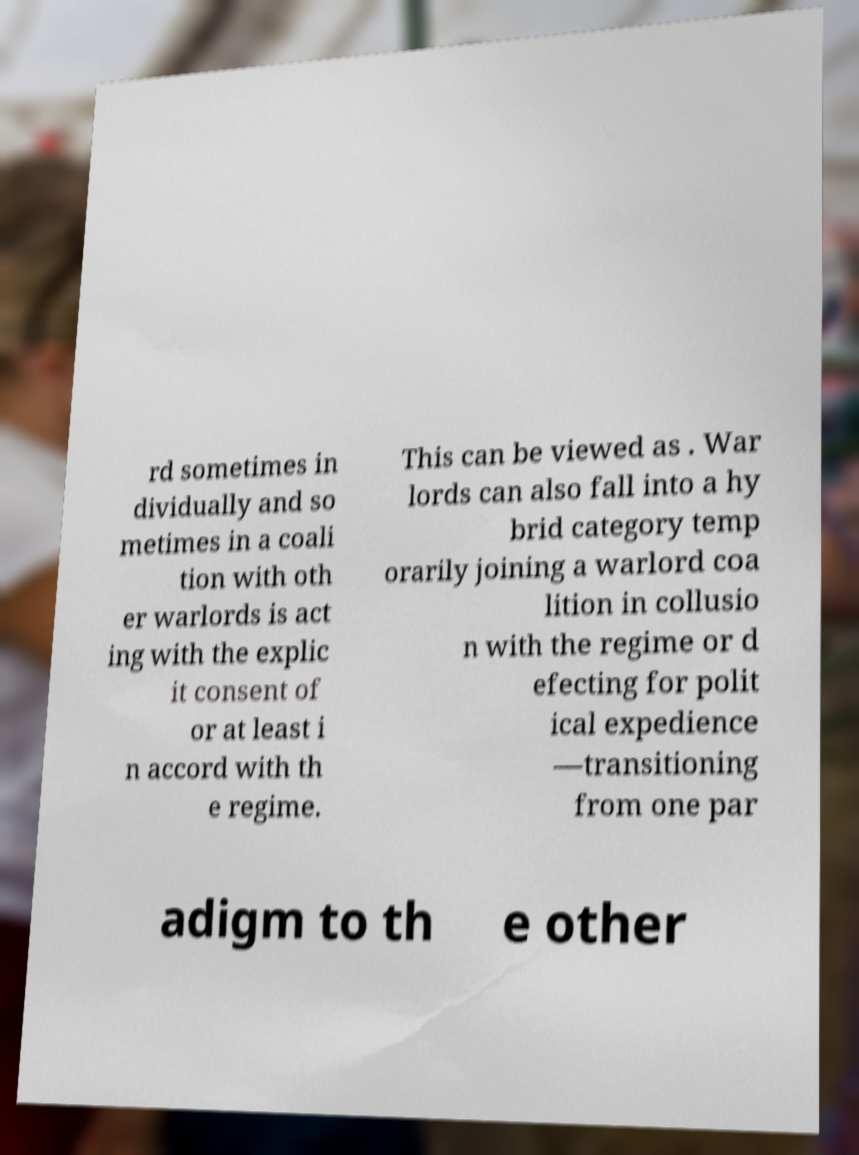Please read and relay the text visible in this image. What does it say? rd sometimes in dividually and so metimes in a coali tion with oth er warlords is act ing with the explic it consent of or at least i n accord with th e regime. This can be viewed as . War lords can also fall into a hy brid category temp orarily joining a warlord coa lition in collusio n with the regime or d efecting for polit ical expedience —transitioning from one par adigm to th e other 